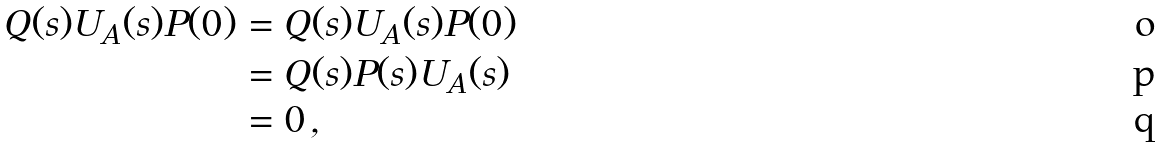<formula> <loc_0><loc_0><loc_500><loc_500>Q ( s ) U _ { A } ( s ) P ( 0 ) & = Q ( s ) U _ { A } ( s ) P ( 0 ) \\ & = Q ( s ) P ( s ) U _ { A } ( s ) \\ & = 0 \, ,</formula> 